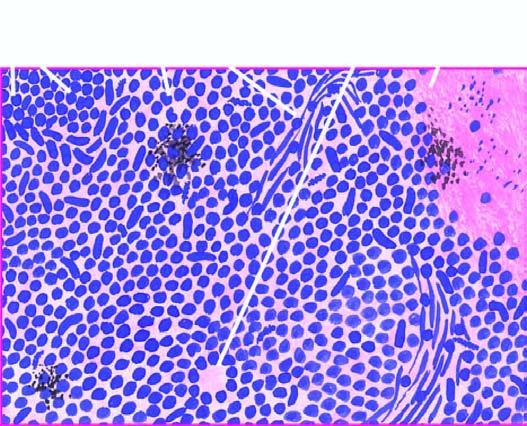what are small, uniform, lymphocyte-like with scanty cytoplasm?
Answer the question using a single word or phrase. Individual tumour cells 